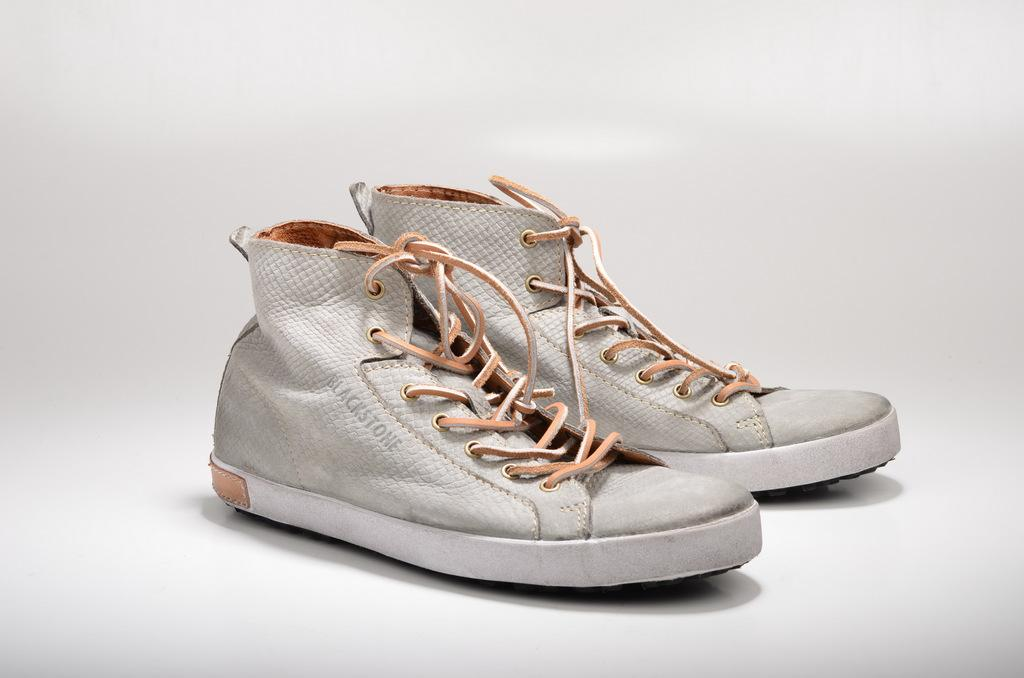What is the color of the background in the image? The background of the image is gray in color. What can be seen in the middle of the image? There are two shoes in the middle of the image. Are the shoes placed on any particular surface? Yes, the shoes are on a surface. How many clovers can be seen growing in the image? There are no clovers present in the image. What type of base is supporting the shoes in the image? The image does not provide enough information to determine the type of base supporting the shoes. 